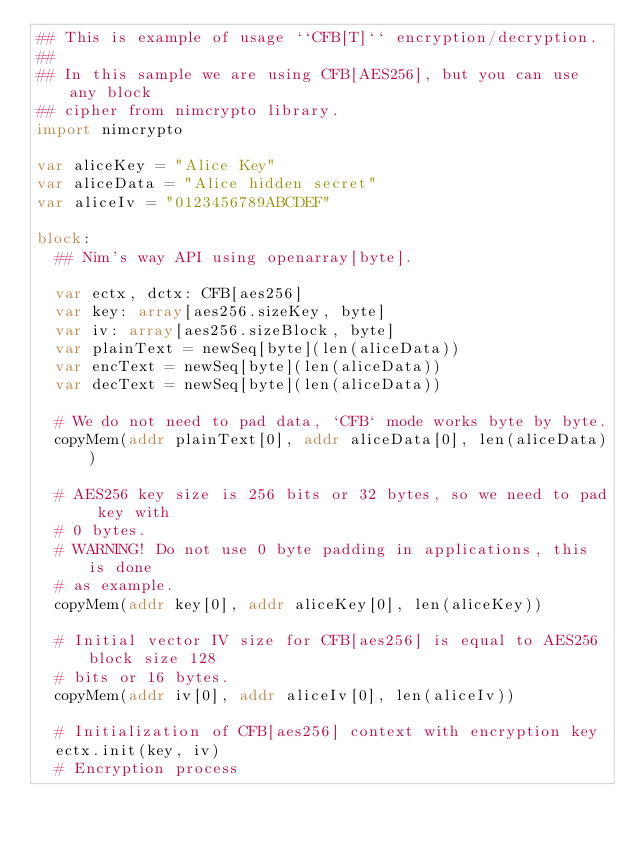Convert code to text. <code><loc_0><loc_0><loc_500><loc_500><_Nim_>## This is example of usage ``CFB[T]`` encryption/decryption.
##
## In this sample we are using CFB[AES256], but you can use any block
## cipher from nimcrypto library.
import nimcrypto

var aliceKey = "Alice Key"
var aliceData = "Alice hidden secret"
var aliceIv = "0123456789ABCDEF"

block:
  ## Nim's way API using openarray[byte].

  var ectx, dctx: CFB[aes256]
  var key: array[aes256.sizeKey, byte]
  var iv: array[aes256.sizeBlock, byte]
  var plainText = newSeq[byte](len(aliceData))
  var encText = newSeq[byte](len(aliceData))
  var decText = newSeq[byte](len(aliceData))

  # We do not need to pad data, `CFB` mode works byte by byte.
  copyMem(addr plainText[0], addr aliceData[0], len(aliceData))

  # AES256 key size is 256 bits or 32 bytes, so we need to pad key with
  # 0 bytes.
  # WARNING! Do not use 0 byte padding in applications, this is done
  # as example.
  copyMem(addr key[0], addr aliceKey[0], len(aliceKey))

  # Initial vector IV size for CFB[aes256] is equal to AES256 block size 128
  # bits or 16 bytes.
  copyMem(addr iv[0], addr aliceIv[0], len(aliceIv))

  # Initialization of CFB[aes256] context with encryption key
  ectx.init(key, iv)
  # Encryption process</code> 